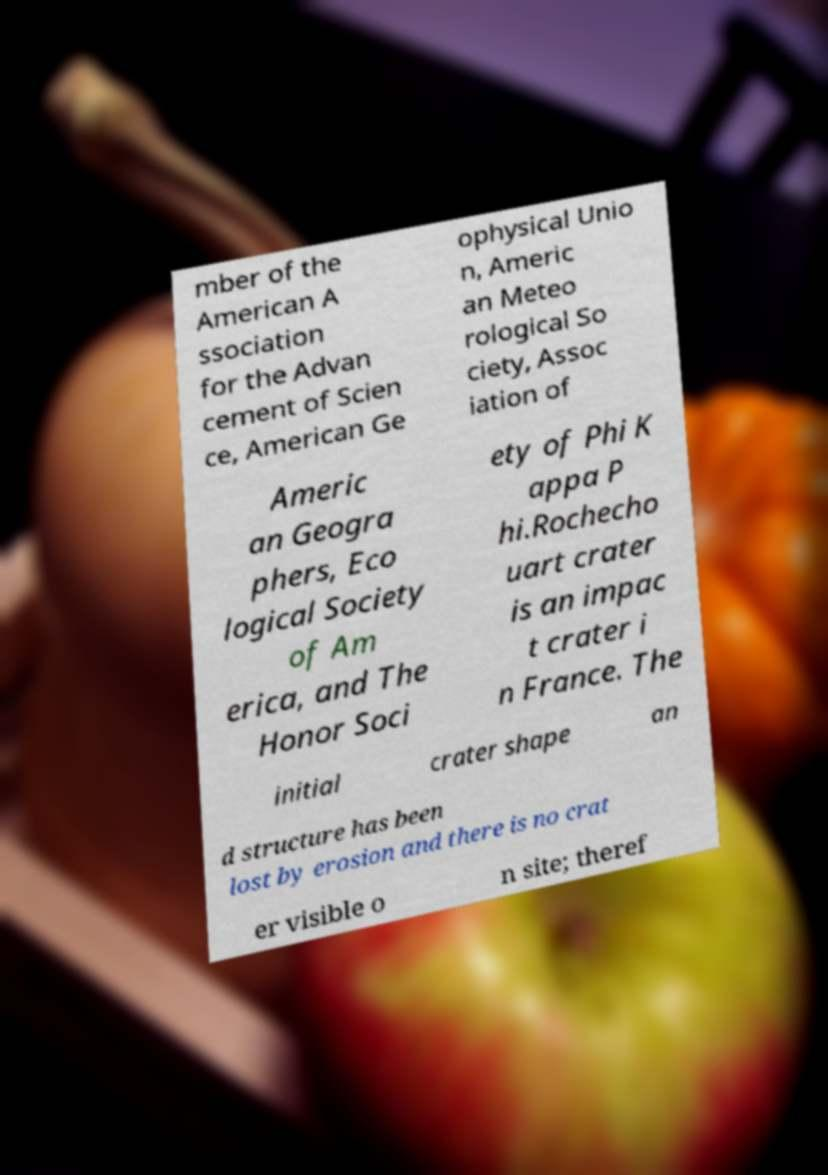I need the written content from this picture converted into text. Can you do that? mber of the American A ssociation for the Advan cement of Scien ce, American Ge ophysical Unio n, Americ an Meteo rological So ciety, Assoc iation of Americ an Geogra phers, Eco logical Society of Am erica, and The Honor Soci ety of Phi K appa P hi.Rochecho uart crater is an impac t crater i n France. The initial crater shape an d structure has been lost by erosion and there is no crat er visible o n site; theref 